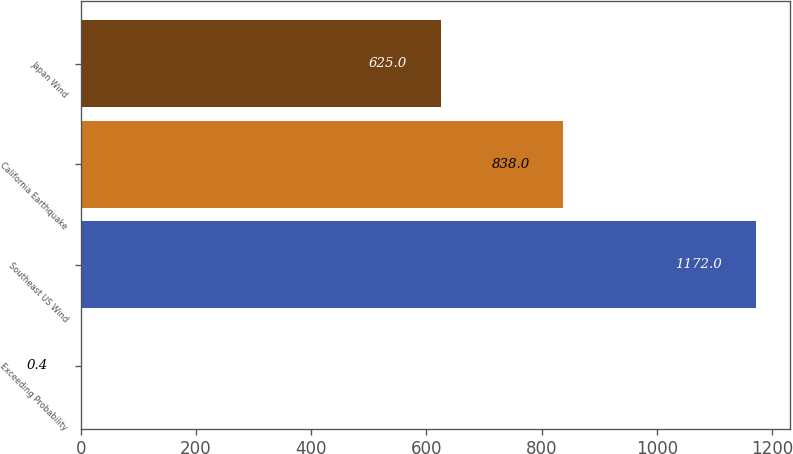Convert chart. <chart><loc_0><loc_0><loc_500><loc_500><bar_chart><fcel>Exceeding Probability<fcel>Southeast US Wind<fcel>California Earthquake<fcel>Japan Wind<nl><fcel>0.4<fcel>1172<fcel>838<fcel>625<nl></chart> 